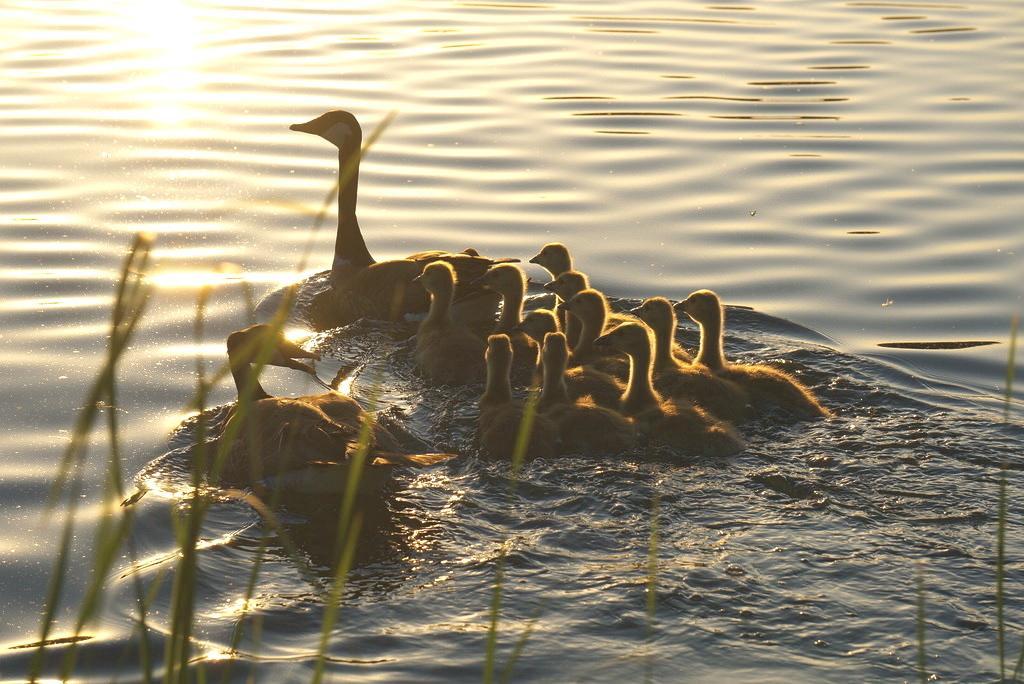How would you summarize this image in a sentence or two? In this picture I can observe ducks swimming in the water. In the bottom of the picture I can observe grass. 